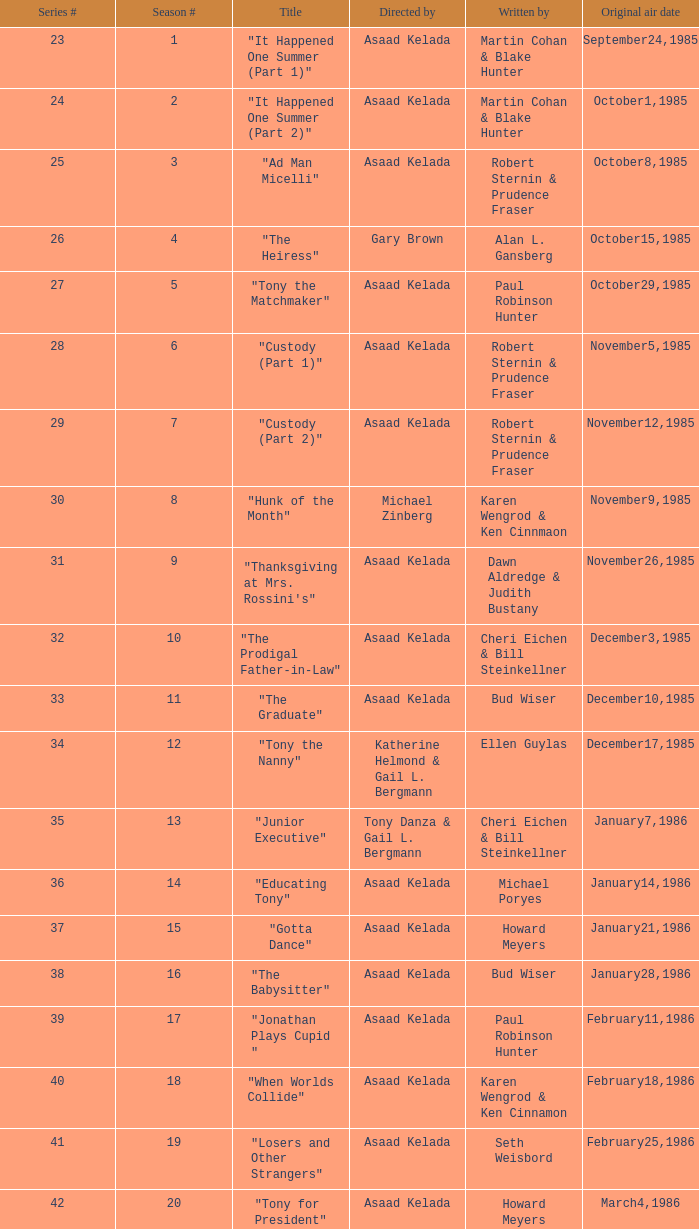Parse the full table. {'header': ['Series #', 'Season #', 'Title', 'Directed by', 'Written by', 'Original air date'], 'rows': [['23', '1', '"It Happened One Summer (Part 1)"', 'Asaad Kelada', 'Martin Cohan & Blake Hunter', 'September24,1985'], ['24', '2', '"It Happened One Summer (Part 2)"', 'Asaad Kelada', 'Martin Cohan & Blake Hunter', 'October1,1985'], ['25', '3', '"Ad Man Micelli"', 'Asaad Kelada', 'Robert Sternin & Prudence Fraser', 'October8,1985'], ['26', '4', '"The Heiress"', 'Gary Brown', 'Alan L. Gansberg', 'October15,1985'], ['27', '5', '"Tony the Matchmaker"', 'Asaad Kelada', 'Paul Robinson Hunter', 'October29,1985'], ['28', '6', '"Custody (Part 1)"', 'Asaad Kelada', 'Robert Sternin & Prudence Fraser', 'November5,1985'], ['29', '7', '"Custody (Part 2)"', 'Asaad Kelada', 'Robert Sternin & Prudence Fraser', 'November12,1985'], ['30', '8', '"Hunk of the Month"', 'Michael Zinberg', 'Karen Wengrod & Ken Cinnmaon', 'November9,1985'], ['31', '9', '"Thanksgiving at Mrs. Rossini\'s"', 'Asaad Kelada', 'Dawn Aldredge & Judith Bustany', 'November26,1985'], ['32', '10', '"The Prodigal Father-in-Law"', 'Asaad Kelada', 'Cheri Eichen & Bill Steinkellner', 'December3,1985'], ['33', '11', '"The Graduate"', 'Asaad Kelada', 'Bud Wiser', 'December10,1985'], ['34', '12', '"Tony the Nanny"', 'Katherine Helmond & Gail L. Bergmann', 'Ellen Guylas', 'December17,1985'], ['35', '13', '"Junior Executive"', 'Tony Danza & Gail L. Bergmann', 'Cheri Eichen & Bill Steinkellner', 'January7,1986'], ['36', '14', '"Educating Tony"', 'Asaad Kelada', 'Michael Poryes', 'January14,1986'], ['37', '15', '"Gotta Dance"', 'Asaad Kelada', 'Howard Meyers', 'January21,1986'], ['38', '16', '"The Babysitter"', 'Asaad Kelada', 'Bud Wiser', 'January28,1986'], ['39', '17', '"Jonathan Plays Cupid "', 'Asaad Kelada', 'Paul Robinson Hunter', 'February11,1986'], ['40', '18', '"When Worlds Collide"', 'Asaad Kelada', 'Karen Wengrod & Ken Cinnamon', 'February18,1986'], ['41', '19', '"Losers and Other Strangers"', 'Asaad Kelada', 'Seth Weisbord', 'February25,1986'], ['42', '20', '"Tony for President"', 'Asaad Kelada', 'Howard Meyers', 'March4,1986'], ['43', '21', '"Not With My Client, You Don\'t"', 'Asaad Kelada', 'Dawn Aldredge & Judith Bustany', 'March18,1986'], ['45', '23', '"There\'s No Business Like Shoe Business"', 'Asaad Kelada', 'Karen Wengrod & Ken Cinnamon', 'April1,1986'], ['46', '24', '"The Unnatural"', 'Jim Drake', 'Ellen Guylas', 'April8,1986']]} What is the date of the episode written by Michael Poryes? January14,1986. 